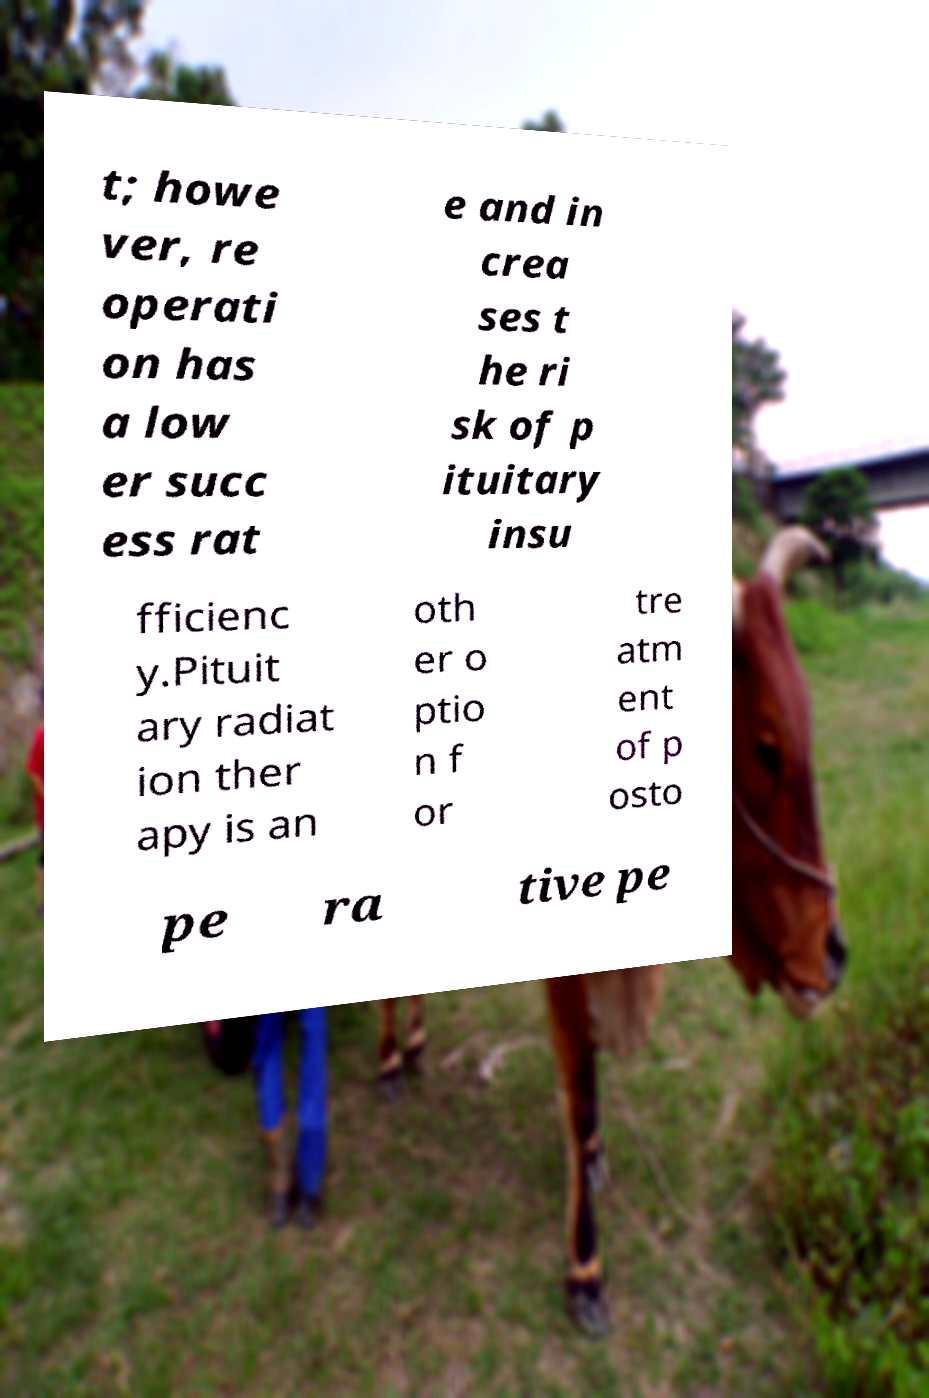Could you extract and type out the text from this image? t; howe ver, re operati on has a low er succ ess rat e and in crea ses t he ri sk of p ituitary insu fficienc y.Pituit ary radiat ion ther apy is an oth er o ptio n f or tre atm ent of p osto pe ra tive pe 